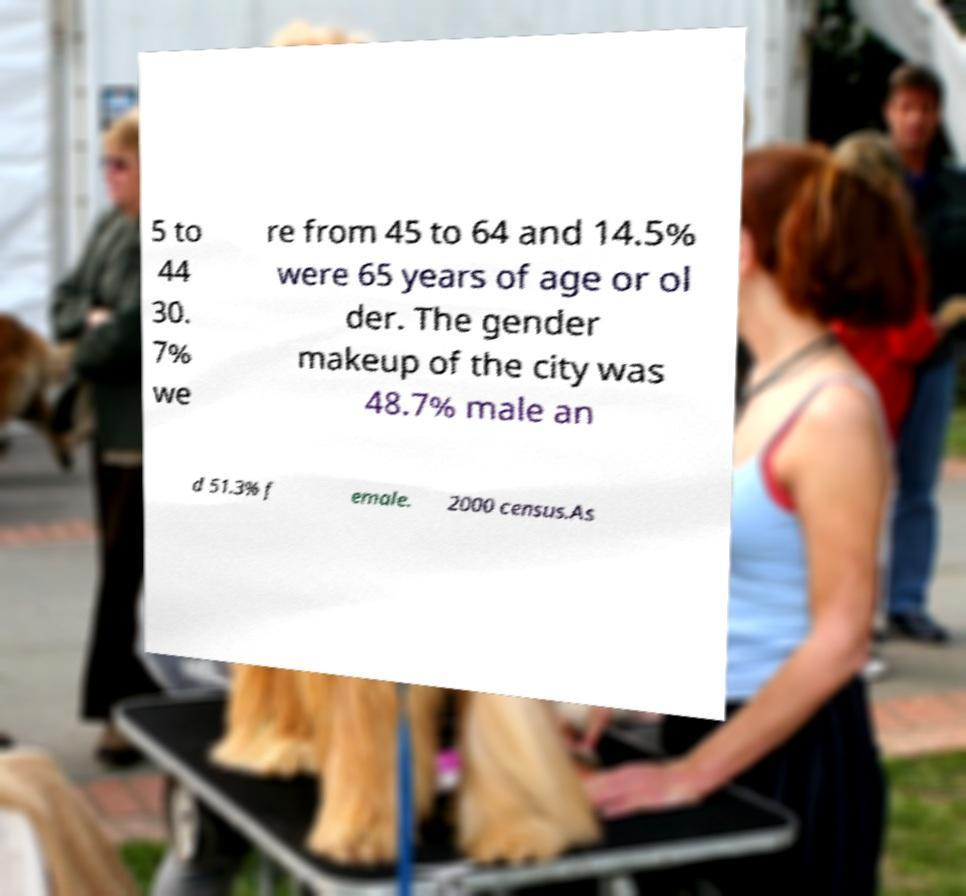What messages or text are displayed in this image? I need them in a readable, typed format. 5 to 44 30. 7% we re from 45 to 64 and 14.5% were 65 years of age or ol der. The gender makeup of the city was 48.7% male an d 51.3% f emale. 2000 census.As 